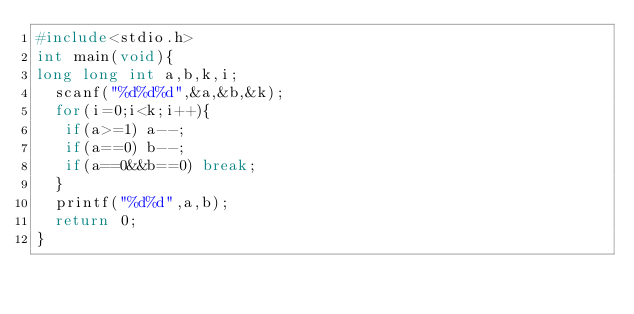Convert code to text. <code><loc_0><loc_0><loc_500><loc_500><_C_>#include<stdio.h>
int main(void){
long long int a,b,k,i;
  scanf("%d%d%d",&a,&b,&k);
  for(i=0;i<k;i++){
   if(a>=1) a--;
   if(a==0) b--;
   if(a==0&&b==0) break;
  }
  printf("%d%d",a,b);
  return 0;
}</code> 